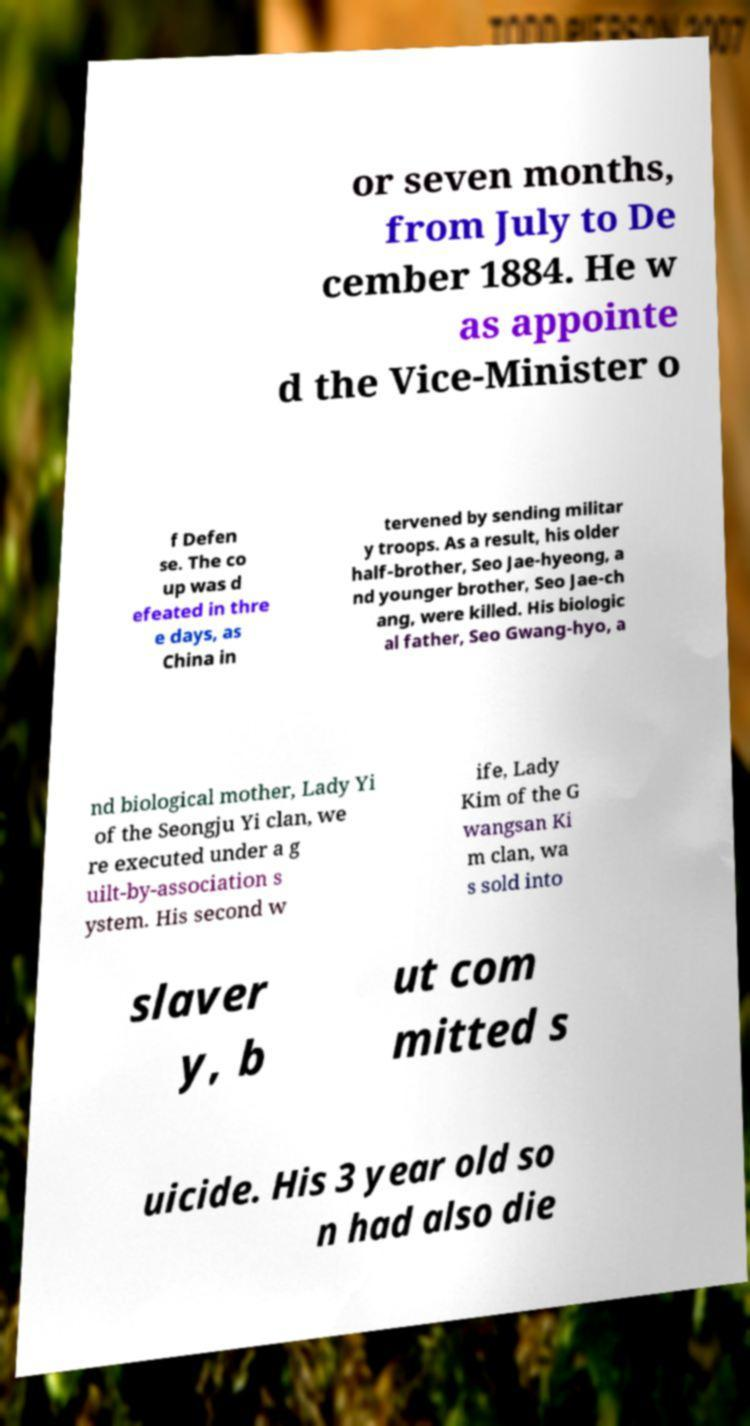Could you extract and type out the text from this image? or seven months, from July to De cember 1884. He w as appointe d the Vice-Minister o f Defen se. The co up was d efeated in thre e days, as China in tervened by sending militar y troops. As a result, his older half-brother, Seo Jae-hyeong, a nd younger brother, Seo Jae-ch ang, were killed. His biologic al father, Seo Gwang-hyo, a nd biological mother, Lady Yi of the Seongju Yi clan, we re executed under a g uilt-by-association s ystem. His second w ife, Lady Kim of the G wangsan Ki m clan, wa s sold into slaver y, b ut com mitted s uicide. His 3 year old so n had also die 